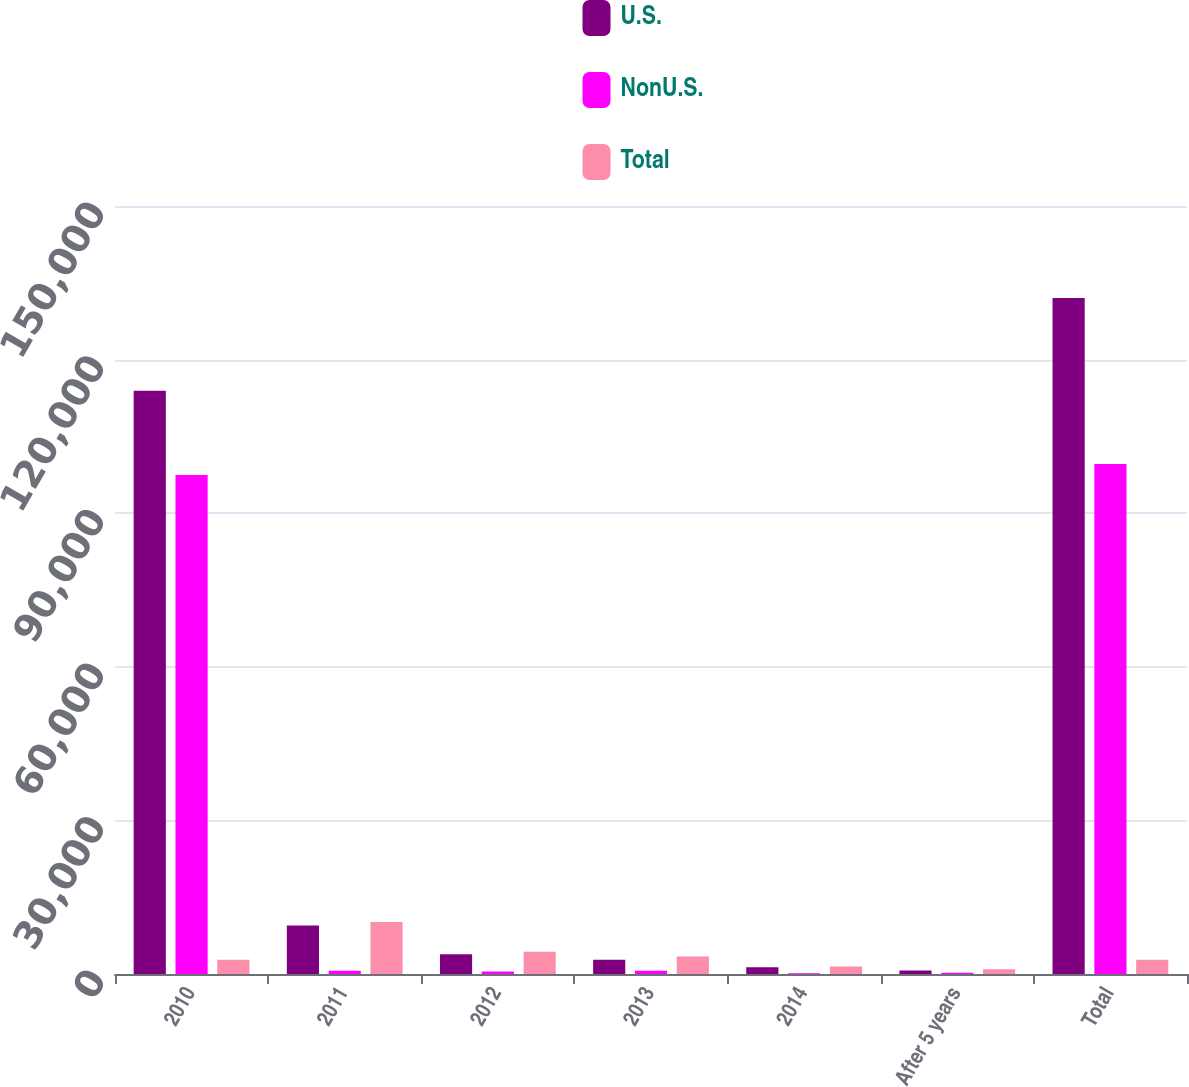Convert chart to OTSL. <chart><loc_0><loc_0><loc_500><loc_500><stacked_bar_chart><ecel><fcel>2010<fcel>2011<fcel>2012<fcel>2013<fcel>2014<fcel>After 5 years<fcel>Total<nl><fcel>U.S.<fcel>113912<fcel>9489<fcel>3851<fcel>2783<fcel>1321<fcel>671<fcel>132027<nl><fcel>NonU.S.<fcel>97465<fcel>654<fcel>485<fcel>634<fcel>127<fcel>267<fcel>99632<nl><fcel>Total<fcel>2783<fcel>10143<fcel>4336<fcel>3417<fcel>1448<fcel>938<fcel>2783<nl></chart> 